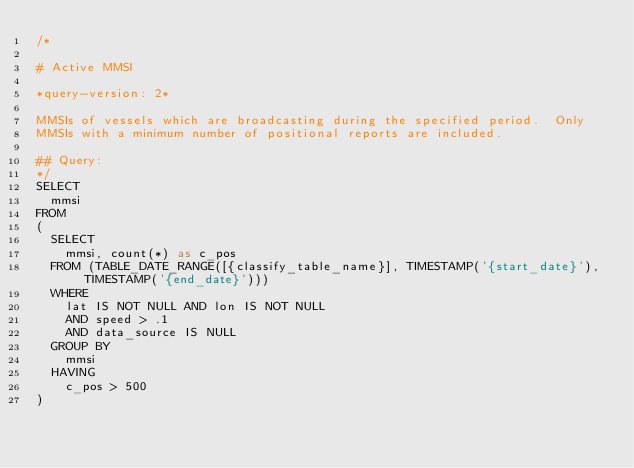Convert code to text. <code><loc_0><loc_0><loc_500><loc_500><_SQL_>/* 

# Active MMSI

*query-version: 2* 

MMSIs of vessels which are broadcasting during the specified period.  Only
MMSIs with a minimum number of positional reports are included.

## Query:
*/
SELECT
  mmsi
FROM
(
  SELECT
    mmsi, count(*) as c_pos
  FROM (TABLE_DATE_RANGE([{classify_table_name}], TIMESTAMP('{start_date}'), TIMESTAMP('{end_date}')))
  WHERE
    lat IS NOT NULL AND lon IS NOT NULL
    AND speed > .1 
    AND data_source IS NULL
  GROUP BY
    mmsi
  HAVING
    c_pos > 500
)
</code> 